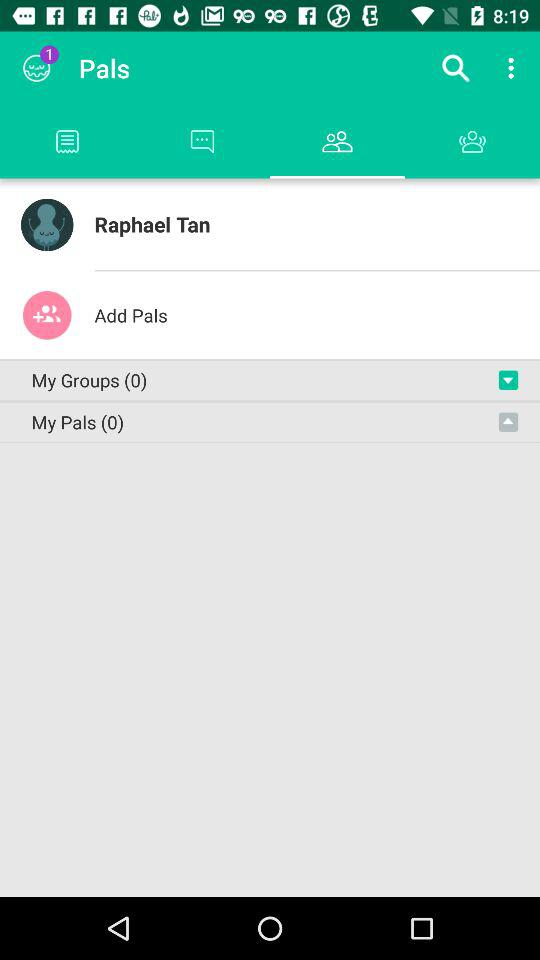What is the name of the user? The name of the user is Raphael Tan. 